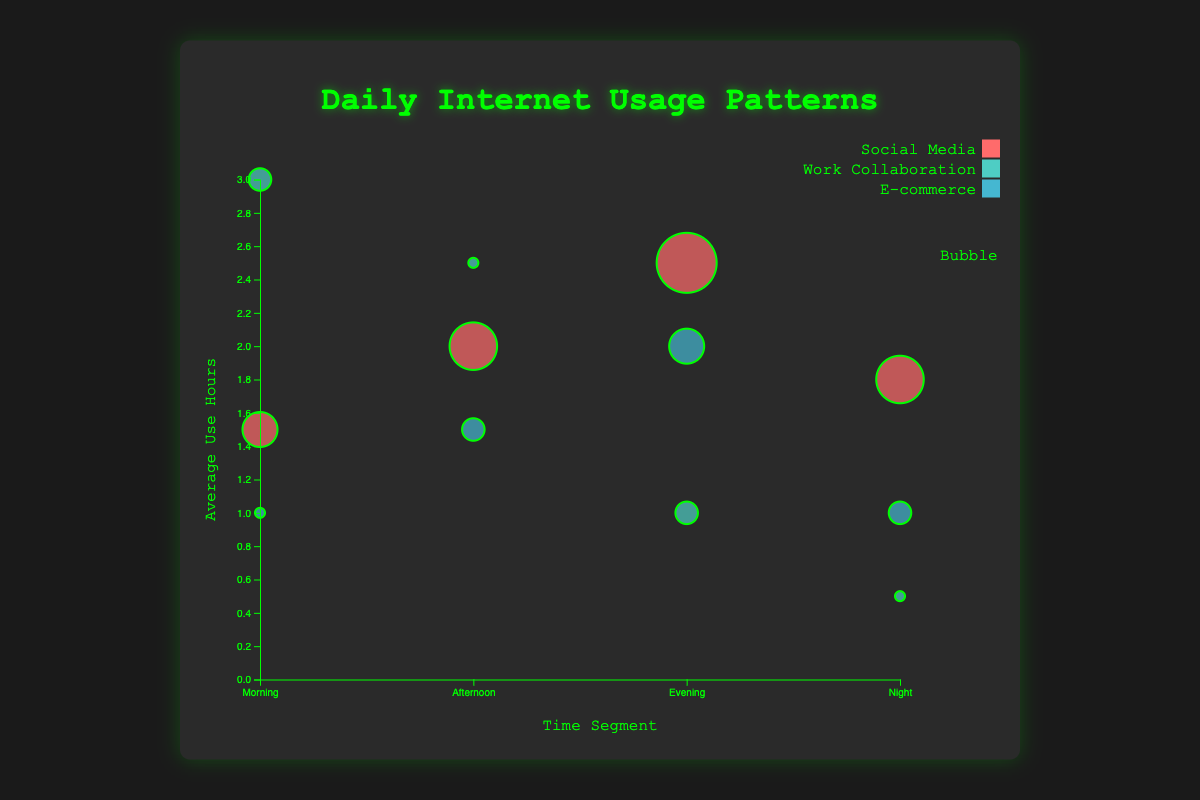What's the title of the chart? The title is typically placed at the top of the chart and in bold to grab attention. In this bubble chart, the title is "Daily Internet Usage Patterns".
Answer: Daily Internet Usage Patterns What does the x-axis represent? The x-axis, typically at the bottom of a chart, is labeled to indicate the category it represents. Here, the x-axis is labeled "Time Segment".
Answer: Time Segment Which application type has the most security incidents in the "Evening"? Check the bubbles under "Evening" and compare their sizes. The greater the size, the more security incidents. The largest bubble under "Evening" is for "Social Media".
Answer: Social Media During which time segment is the average use of "Work Collaboration" highest? Look for bubbles representing "Work Collaboration" and identify their highest position along the y-axis. The highest point for "Work Collaboration" is in the "Morning".
Answer: Morning How many security incidents are reported in "E-commerce" during the "Afternoon"? Find the bubble corresponding to "E-commerce" in the "Afternoon" segment, and check the size/symbol indicating the number of security incidents. There is one security incident.
Answer: One Which application type has no security incidents reported during "Morning"? Identify the bubbles under "Morning" with no size/indicating zero incidents. "E-commerce" has no size under "Morning".
Answer: E-commerce Compare the average use hours of "Social Media" in the "Morning" and "Night". Which one is higher? Look at the positions of "Social Media" bubbles under "Morning" and "Night" on the y-axis. The "Morning" bubble is at 1.5 and the "Night" bubble is at 1.8. So, "Night" is higher.
Answer: Night What is the sum of security incidents for "Social Media" in "Morning" and "Afternoon"? Add the number of security incidents for "Social Media" in the "Morning" and "Afternoon". In the "Morning" it is 2, and in the "Afternoon" it is 3, so 2 + 3 = 5.
Answer: 5 Which time segment has the lowest average use hours for "Work Collaboration"? Compare the "Work Collaboration" bubbles across all time segments and find the lowest y-position. The "Night" has the lowest with 0.5 hours.
Answer: Night 